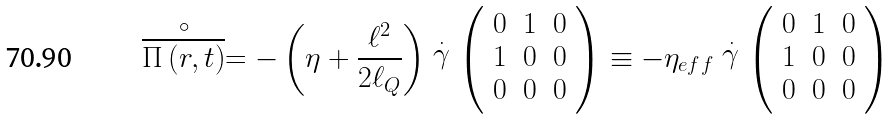Convert formula to latex. <formula><loc_0><loc_0><loc_500><loc_500>\stackrel { \circ } { \overline { { \Pi } \left ( { r } , t \right ) } } = - \left ( \eta + \frac { \ell ^ { 2 } } { 2 \ell _ { Q } } \right ) \stackrel { . } { \gamma } \left ( \begin{array} { c c c } 0 & 1 & 0 \\ 1 & 0 & 0 \\ 0 & 0 & 0 \end{array} \right ) \equiv - \eta _ { e f f } \stackrel { . } { \gamma } \left ( \begin{array} { c c c } 0 & 1 & 0 \\ 1 & 0 & 0 \\ 0 & 0 & 0 \end{array} \right )</formula> 